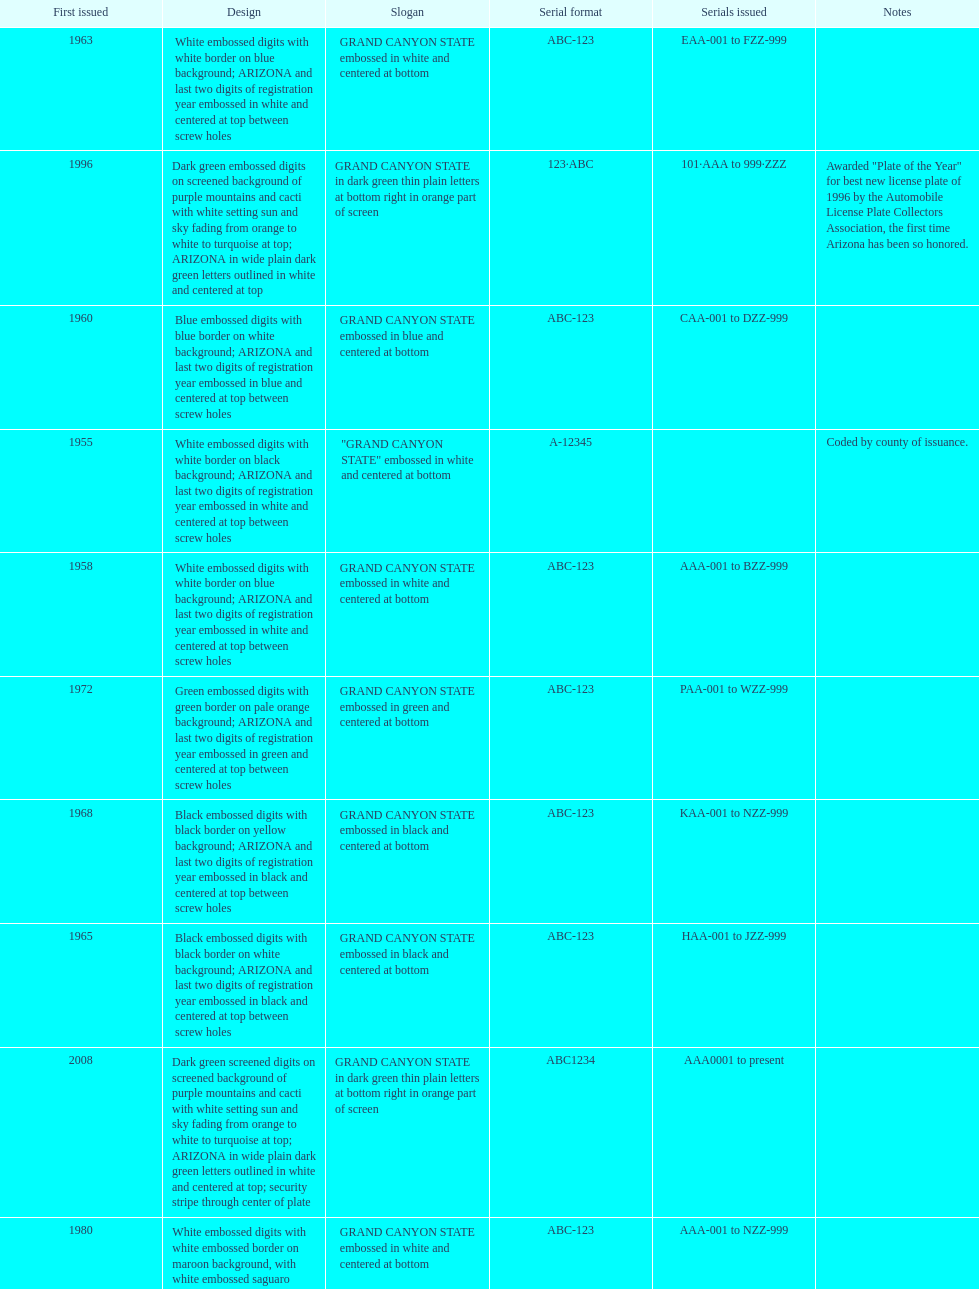What was year was the first arizona license plate made? 1955. 